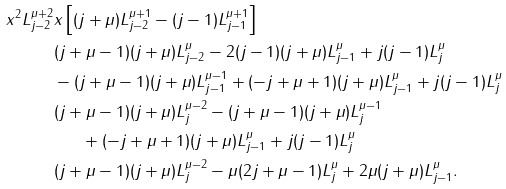Convert formula to latex. <formula><loc_0><loc_0><loc_500><loc_500>x ^ { 2 } L _ { j - 2 } ^ { \mu + 2 } & x \left [ ( j + \mu ) L _ { j - 2 } ^ { \mu + 1 } - ( j - 1 ) L _ { j - 1 } ^ { \mu + 1 } \right ] \\ & ( j + \mu - 1 ) ( j + \mu ) L _ { j - 2 } ^ { \mu } - 2 ( j - 1 ) ( j + \mu ) L _ { j - 1 } ^ { \mu } + j ( j - 1 ) L _ { j } ^ { \mu } \\ & - ( j + \mu - 1 ) ( j + \mu ) L _ { j - 1 } ^ { \mu - 1 } + ( - j + \mu + 1 ) ( j + \mu ) L _ { j - 1 } ^ { \mu } + j ( j - 1 ) L _ { j } ^ { \mu } \\ & ( j + \mu - 1 ) ( j + \mu ) L _ { j } ^ { \mu - 2 } - ( j + \mu - 1 ) ( j + \mu ) L _ { j } ^ { \mu - 1 } \\ & \quad \ \ + ( - j + \mu + 1 ) ( j + \mu ) L _ { j - 1 } ^ { \mu } + j ( j - 1 ) L _ { j } ^ { \mu } \\ & ( j + \mu - 1 ) ( j + \mu ) L _ { j } ^ { \mu - 2 } - \mu ( 2 j + \mu - 1 ) L _ { j } ^ { \mu } + 2 \mu ( j + \mu ) L _ { j - 1 } ^ { \mu } .</formula> 